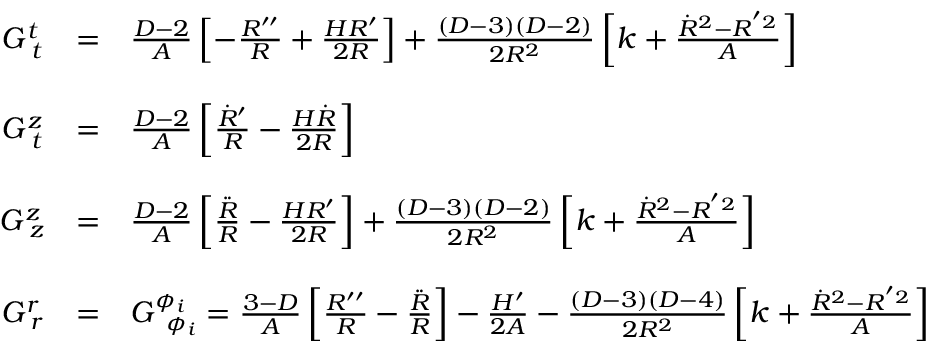Convert formula to latex. <formula><loc_0><loc_0><loc_500><loc_500>\begin{array} { c c l } { { G _ { \, t } ^ { t } } } & { = } & { { \frac { D - 2 } { A } \left [ - \frac { R ^ { \prime \prime } } { R } + \frac { H R ^ { \prime } } { 2 R } \right ] + \frac { ( D - 3 ) ( D - 2 ) } { 2 R ^ { 2 } } \left [ k + \frac { \dot { R } ^ { 2 } - R ^ { ^ { \prime } 2 } } { A } \right ] } } \\ { { G _ { \, t } ^ { z } } } & { = } & { { \frac { D - 2 } { A } \left [ { \frac { \dot { R } ^ { \prime } } { R } } - { \frac { H \dot { R } } { 2 R } } \right ] } } \\ { { G _ { \, z } ^ { z } } } & { = } & { { \frac { D - 2 } { A } \left [ \frac { \ddot { R } } { R } - \frac { H R ^ { \prime } } { 2 R } \right ] + \frac { ( D - 3 ) ( D - 2 ) } { 2 R ^ { 2 } } \left [ k + \frac { \dot { R } ^ { 2 } - R ^ { ^ { \prime } 2 } } { A } \right ] } } \\ { { G _ { \, r } ^ { r } } } & { = } & { { G _ { \, \phi _ { i } } ^ { \phi _ { i } } = \frac { 3 - D } { A } \left [ { \frac { R ^ { \prime \prime } } { R } } - { \frac { \ddot { R } } { R } } \right ] - { \frac { H ^ { \prime } } { 2 A } } - \frac { ( D - 3 ) ( D - 4 ) } { 2 R ^ { 2 } } \left [ k + \frac { \dot { R } ^ { 2 } - R ^ { ^ { \prime } 2 } } { A } \right ] } } \end{array}</formula> 